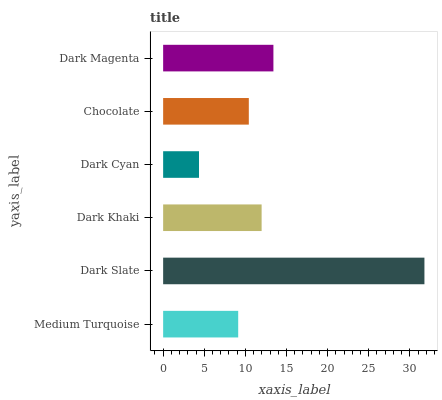Is Dark Cyan the minimum?
Answer yes or no. Yes. Is Dark Slate the maximum?
Answer yes or no. Yes. Is Dark Khaki the minimum?
Answer yes or no. No. Is Dark Khaki the maximum?
Answer yes or no. No. Is Dark Slate greater than Dark Khaki?
Answer yes or no. Yes. Is Dark Khaki less than Dark Slate?
Answer yes or no. Yes. Is Dark Khaki greater than Dark Slate?
Answer yes or no. No. Is Dark Slate less than Dark Khaki?
Answer yes or no. No. Is Dark Khaki the high median?
Answer yes or no. Yes. Is Chocolate the low median?
Answer yes or no. Yes. Is Dark Slate the high median?
Answer yes or no. No. Is Dark Slate the low median?
Answer yes or no. No. 